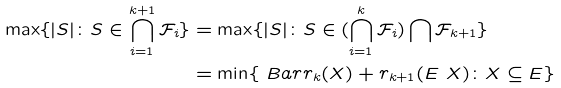<formula> <loc_0><loc_0><loc_500><loc_500>\max \{ | S | \colon S \in \bigcap _ { i = 1 } ^ { k + 1 } \mathcal { F } _ { i } \} & = \max \{ | S | \colon S \in ( \bigcap _ { i = 1 } ^ { k } \mathcal { F } _ { i } ) \bigcap \mathcal { F } _ { k + 1 } \} \\ & = \min \{ \ B a r { r } _ { k } ( X ) + r _ { k + 1 } ( E \ X ) \colon X \subseteq E \}</formula> 